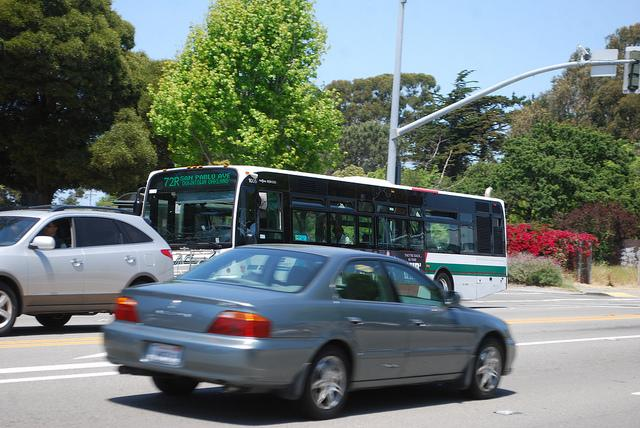How many directions are the vehicles shown going in? two 